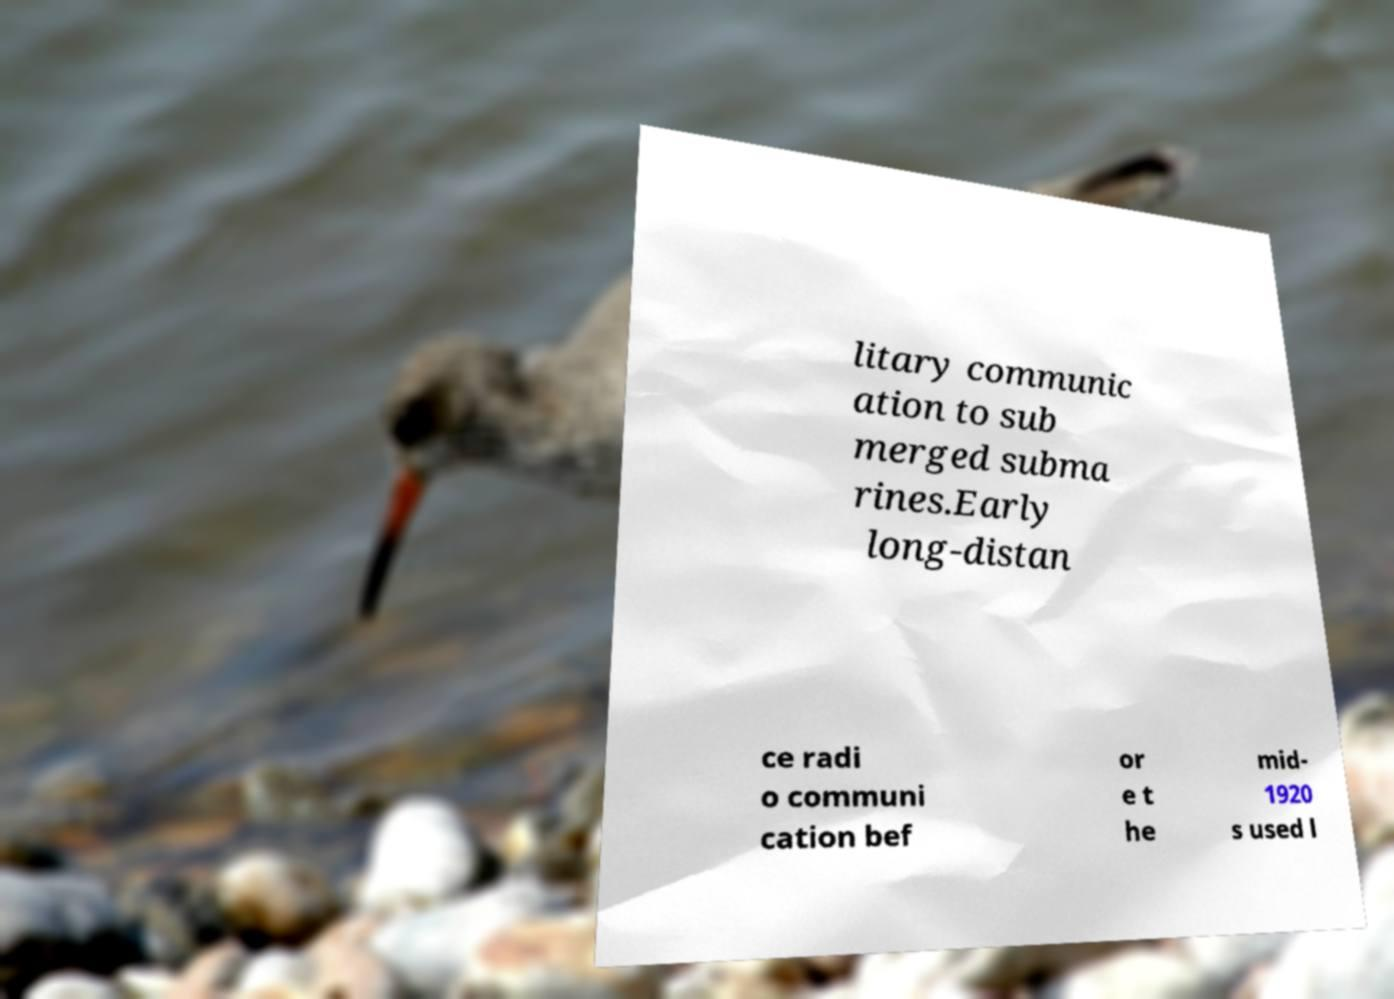Please read and relay the text visible in this image. What does it say? litary communic ation to sub merged subma rines.Early long-distan ce radi o communi cation bef or e t he mid- 1920 s used l 